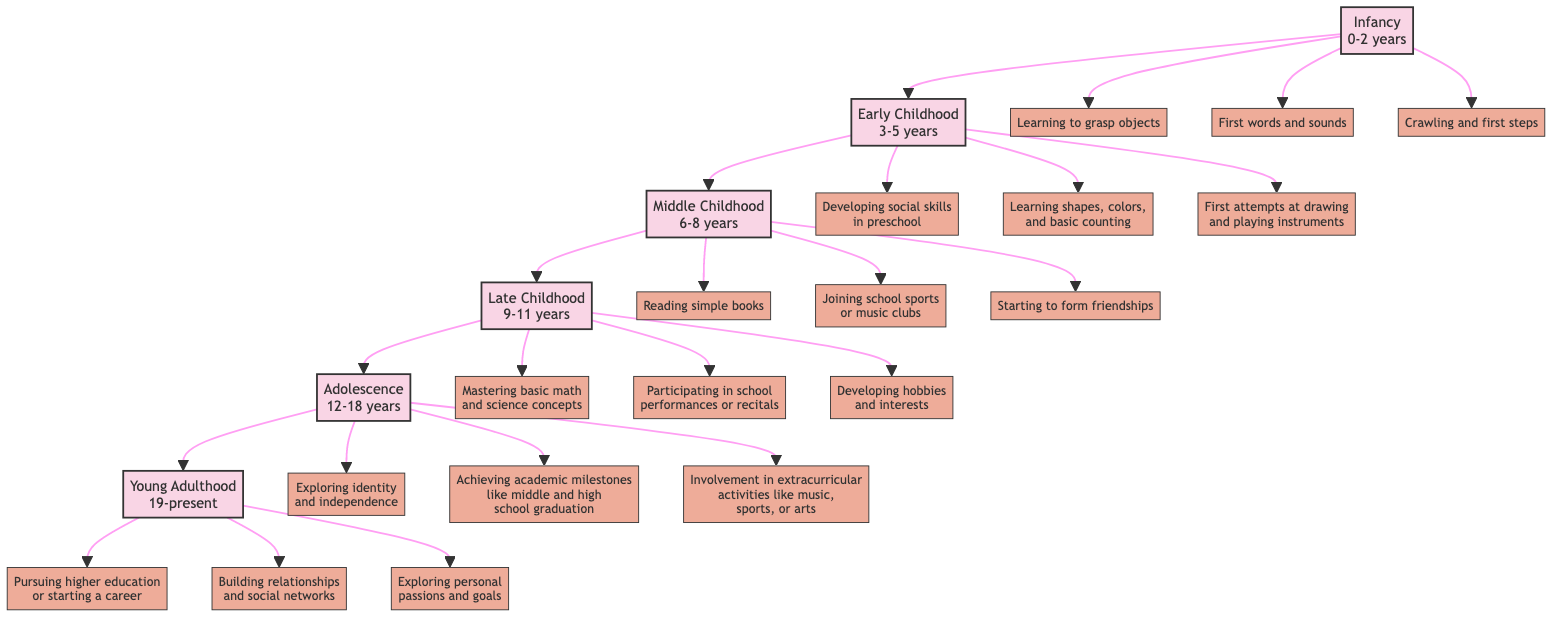What is the age range for Early Childhood? The node for Early Childhood specifies its age range as "3-5 years". This can be found by examining the label attached to the Early Childhood stage.
Answer: 3-5 years How many achievements are listed under Middle Childhood? The Middle Childhood stage lists three achievements: reading simple books, joining school sports or music clubs, and starting to form friendships. Counting these gives a total of three achievements.
Answer: 3 Which stage comes directly before Young Adulthood? The diagram shows the flow from Late Childhood leading up to Young Adulthood. Therefore, identifying the immediate predecessor of Young Adulthood leads us to Late Childhood.
Answer: Late Childhood What are the three achievements in Adolescence? By examining the Adolescence stage, we can list the achievements: exploring identity and independence, achieving academic milestones like middle and high school graduation, and involvement in extracurricular activities like music, sports, or arts.
Answer: Exploring identity and independence, achieving academic milestones, involvement in extracurricular activities Which achievement is specifically related to music in Early Childhood? The achievements in Early Childhood include "First attempts at drawing and playing instruments". The phrase specifically mentions playing instruments, indicating a connection to music.
Answer: First attempts at drawing and playing instruments What is the last achievement listed in the Young Adulthood stage? The achievements under Young Adulthood are listed in a sequential manner, and the last one is "Exploring personal passions and goals". Thus, it is the concluding achievement for this stage.
Answer: Exploring personal passions and goals How many stages of child development are represented in the diagram? By counting the unique stages labeled from Infancy to Young Adulthood, we find a total of six stages represented in the diagram.
Answer: 6 Which stage includes mastering basic math and science concepts? The achievement of mastering basic math and science concepts is listed under the Late Childhood stage, so this would be the relevant stage associated with this achievement.
Answer: Late Childhood What is the first achievement mentioned in Infancy? The first achievement listed under the Infancy stage is "Learning to grasp objects", which can be identified as the initiation of physical interaction with the environment.
Answer: Learning to grasp objects 